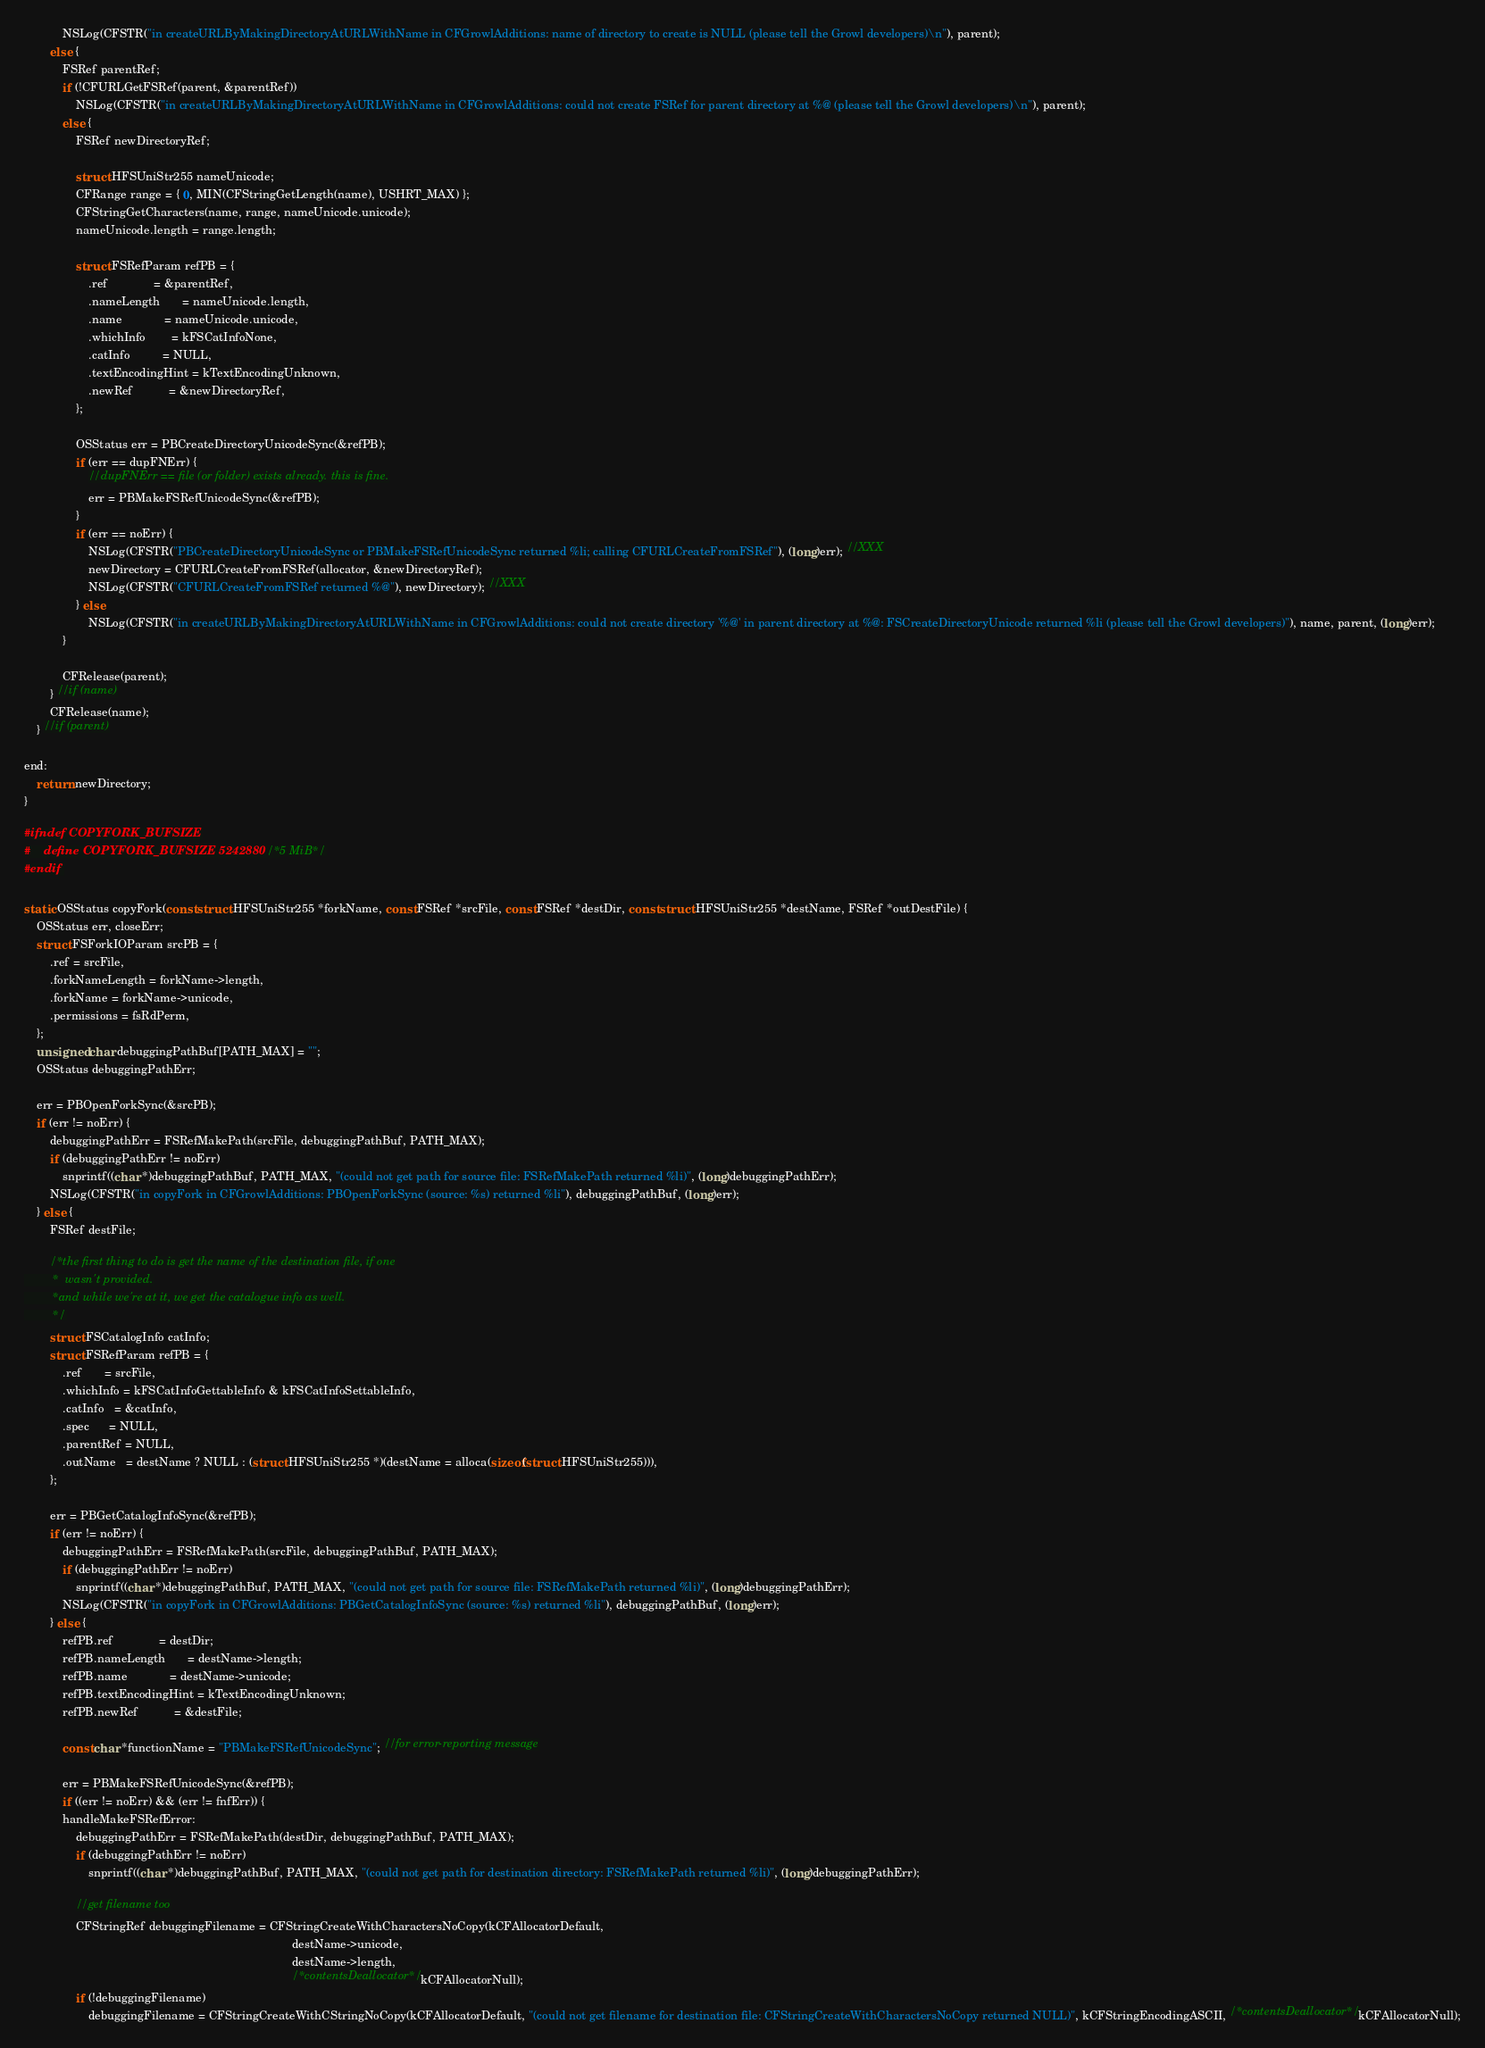<code> <loc_0><loc_0><loc_500><loc_500><_C_>			NSLog(CFSTR("in createURLByMakingDirectoryAtURLWithName in CFGrowlAdditions: name of directory to create is NULL (please tell the Growl developers)\n"), parent);
		else {
			FSRef parentRef;
			if (!CFURLGetFSRef(parent, &parentRef))
				NSLog(CFSTR("in createURLByMakingDirectoryAtURLWithName in CFGrowlAdditions: could not create FSRef for parent directory at %@ (please tell the Growl developers)\n"), parent);
			else {
				FSRef newDirectoryRef;

				struct HFSUniStr255 nameUnicode;
				CFRange range = { 0, MIN(CFStringGetLength(name), USHRT_MAX) };
				CFStringGetCharacters(name, range, nameUnicode.unicode);
				nameUnicode.length = range.length;

				struct FSRefParam refPB = {
					.ref              = &parentRef,
					.nameLength       = nameUnicode.length,
					.name             = nameUnicode.unicode,
					.whichInfo        = kFSCatInfoNone,
					.catInfo          = NULL,
					.textEncodingHint = kTextEncodingUnknown,
					.newRef           = &newDirectoryRef,
				};

				OSStatus err = PBCreateDirectoryUnicodeSync(&refPB);
				if (err == dupFNErr) {
					//dupFNErr == file (or folder) exists already. this is fine.
					err = PBMakeFSRefUnicodeSync(&refPB);
				}
				if (err == noErr) {
					NSLog(CFSTR("PBCreateDirectoryUnicodeSync or PBMakeFSRefUnicodeSync returned %li; calling CFURLCreateFromFSRef"), (long)err); //XXX
					newDirectory = CFURLCreateFromFSRef(allocator, &newDirectoryRef);
					NSLog(CFSTR("CFURLCreateFromFSRef returned %@"), newDirectory); //XXX
				} else
					NSLog(CFSTR("in createURLByMakingDirectoryAtURLWithName in CFGrowlAdditions: could not create directory '%@' in parent directory at %@: FSCreateDirectoryUnicode returned %li (please tell the Growl developers)"), name, parent, (long)err);
			}

			CFRelease(parent);
		} //if (name)
		CFRelease(name);
	} //if (parent)

end:
	return newDirectory;
}

#ifndef COPYFORK_BUFSIZE
#	define COPYFORK_BUFSIZE 5242880U /*5 MiB*/
#endif

static OSStatus copyFork(const struct HFSUniStr255 *forkName, const FSRef *srcFile, const FSRef *destDir, const struct HFSUniStr255 *destName, FSRef *outDestFile) {
	OSStatus err, closeErr;
	struct FSForkIOParam srcPB = {
		.ref = srcFile,
		.forkNameLength = forkName->length,
		.forkName = forkName->unicode,
		.permissions = fsRdPerm,
	};
	unsigned char debuggingPathBuf[PATH_MAX] = "";
	OSStatus debuggingPathErr;

	err = PBOpenForkSync(&srcPB);
	if (err != noErr) {
		debuggingPathErr = FSRefMakePath(srcFile, debuggingPathBuf, PATH_MAX);
		if (debuggingPathErr != noErr)
			snprintf((char *)debuggingPathBuf, PATH_MAX, "(could not get path for source file: FSRefMakePath returned %li)", (long)debuggingPathErr);
		NSLog(CFSTR("in copyFork in CFGrowlAdditions: PBOpenForkSync (source: %s) returned %li"), debuggingPathBuf, (long)err);
	} else {
		FSRef destFile;

		/*the first thing to do is get the name of the destination file, if one
		 *	wasn't provided.
		 *and while we're at it, we get the catalogue info as well.
		 */
		struct FSCatalogInfo catInfo;
		struct FSRefParam refPB = {
			.ref       = srcFile,
			.whichInfo = kFSCatInfoGettableInfo & kFSCatInfoSettableInfo,
			.catInfo   = &catInfo,
			.spec      = NULL,
			.parentRef = NULL,
			.outName   = destName ? NULL : (struct HFSUniStr255 *)(destName = alloca(sizeof(struct HFSUniStr255))),
		};

		err = PBGetCatalogInfoSync(&refPB);
		if (err != noErr) {
			debuggingPathErr = FSRefMakePath(srcFile, debuggingPathBuf, PATH_MAX);
			if (debuggingPathErr != noErr)
				snprintf((char *)debuggingPathBuf, PATH_MAX, "(could not get path for source file: FSRefMakePath returned %li)", (long)debuggingPathErr);
			NSLog(CFSTR("in copyFork in CFGrowlAdditions: PBGetCatalogInfoSync (source: %s) returned %li"), debuggingPathBuf, (long)err);
		} else {
			refPB.ref              = destDir;
			refPB.nameLength       = destName->length;
			refPB.name             = destName->unicode;
			refPB.textEncodingHint = kTextEncodingUnknown;
			refPB.newRef           = &destFile;

			const char *functionName = "PBMakeFSRefUnicodeSync"; //for error-reporting message

			err = PBMakeFSRefUnicodeSync(&refPB);
			if ((err != noErr) && (err != fnfErr)) {
			handleMakeFSRefError:
				debuggingPathErr = FSRefMakePath(destDir, debuggingPathBuf, PATH_MAX);
				if (debuggingPathErr != noErr)
					snprintf((char *)debuggingPathBuf, PATH_MAX, "(could not get path for destination directory: FSRefMakePath returned %li)", (long)debuggingPathErr);

				//get filename too
				CFStringRef debuggingFilename = CFStringCreateWithCharactersNoCopy(kCFAllocatorDefault,
																				   destName->unicode,
																				   destName->length,
																				   /*contentsDeallocator*/ kCFAllocatorNull);
				if (!debuggingFilename)
					debuggingFilename = CFStringCreateWithCStringNoCopy(kCFAllocatorDefault, "(could not get filename for destination file: CFStringCreateWithCharactersNoCopy returned NULL)", kCFStringEncodingASCII, /*contentsDeallocator*/ kCFAllocatorNull);
</code> 